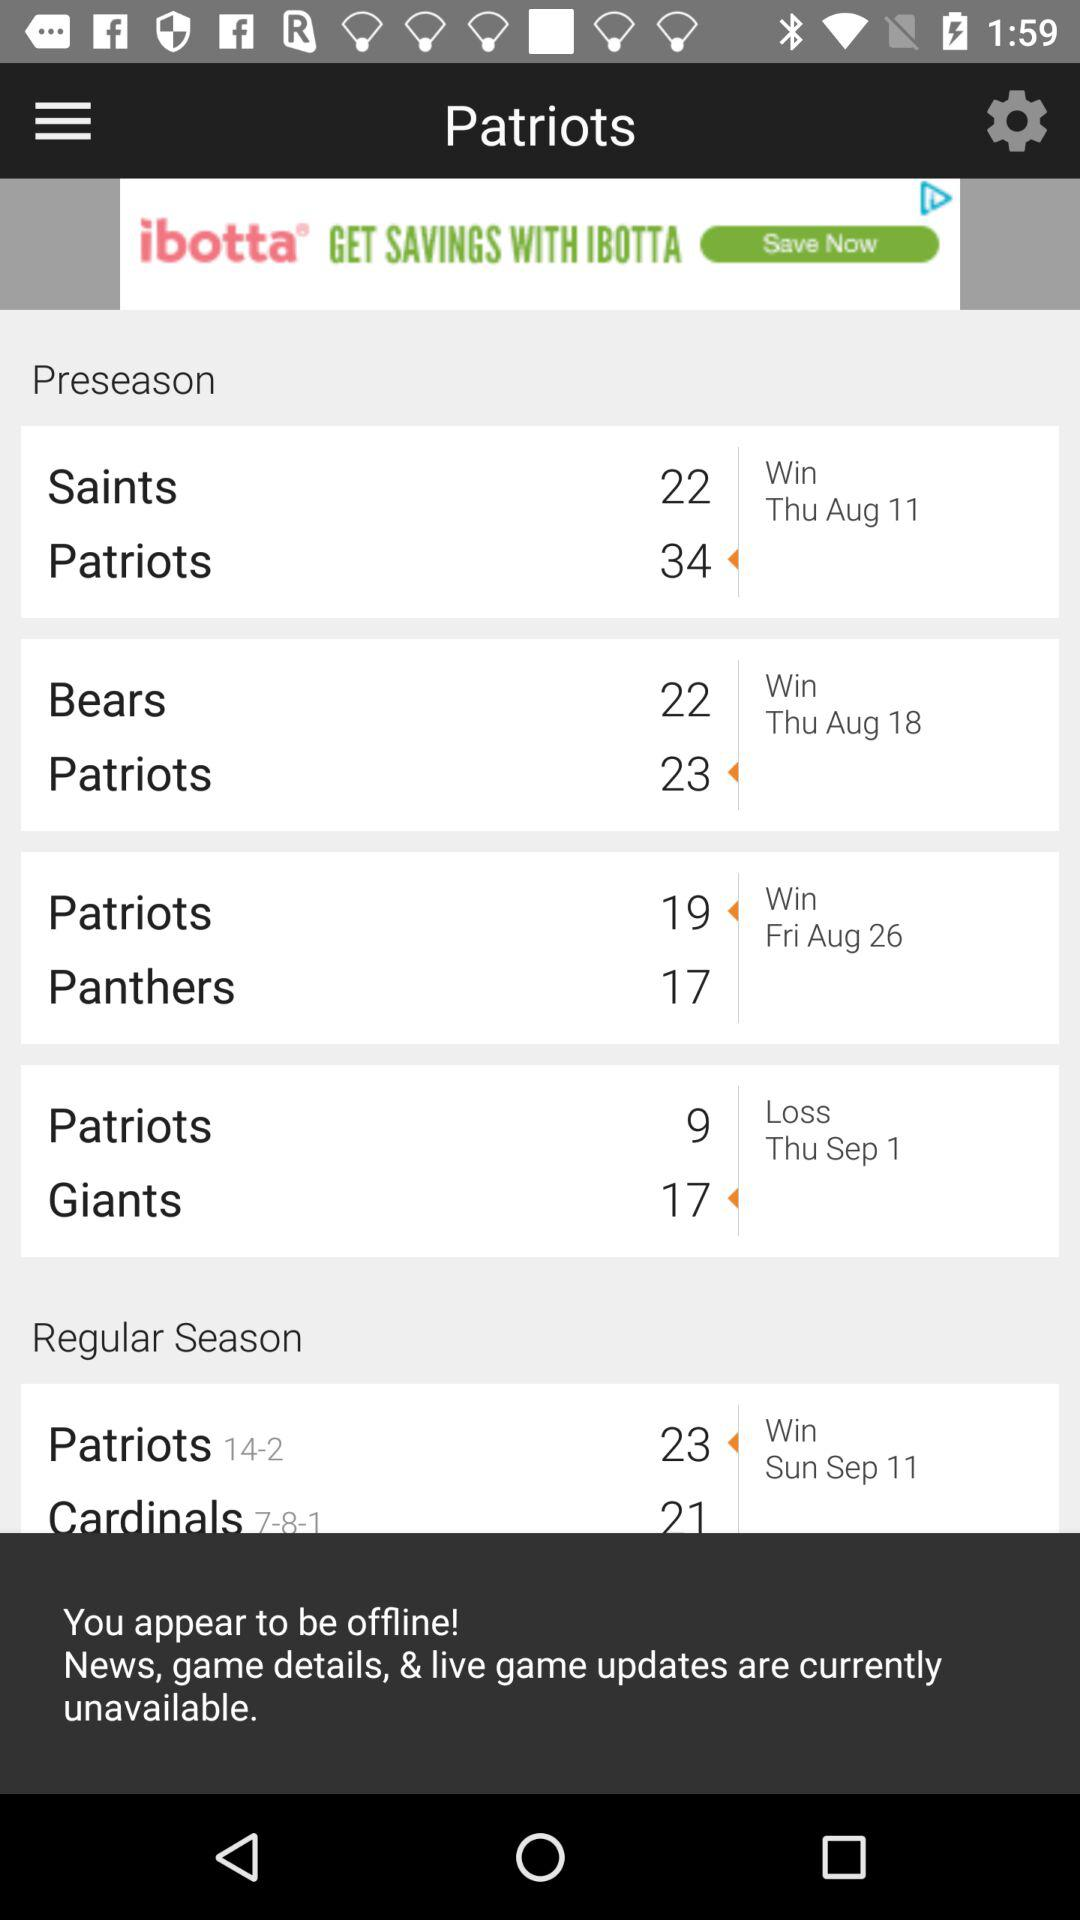Who won the preseason match on Thursday, 11 August? The preseason match was won by the Patriots. 